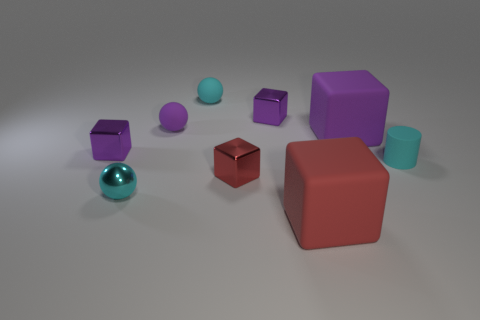There is a small purple shiny thing in front of the shiny thing behind the big block that is behind the small cylinder; what shape is it? The object in question is a small purple cube. Its color and reflective surface make it stand out, indicating the object's geometry perfectly complements its surroundings. 